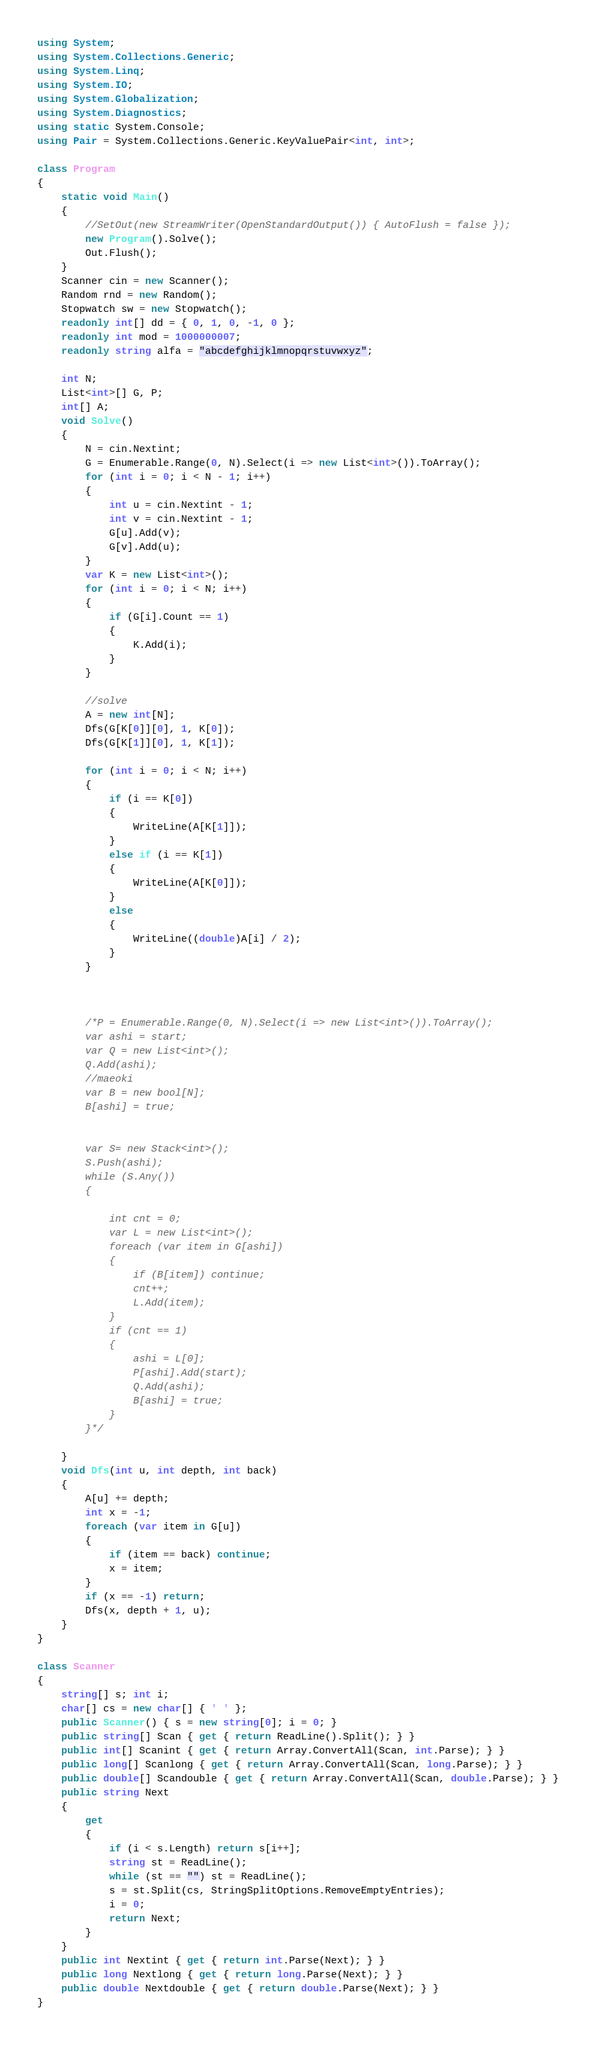<code> <loc_0><loc_0><loc_500><loc_500><_C#_>using System;
using System.Collections.Generic;
using System.Linq;
using System.IO;
using System.Globalization;
using System.Diagnostics;
using static System.Console;
using Pair = System.Collections.Generic.KeyValuePair<int, int>;

class Program
{
    static void Main()
    {
        //SetOut(new StreamWriter(OpenStandardOutput()) { AutoFlush = false });
        new Program().Solve();
        Out.Flush();
    }
    Scanner cin = new Scanner();
    Random rnd = new Random();
    Stopwatch sw = new Stopwatch();
    readonly int[] dd = { 0, 1, 0, -1, 0 };
    readonly int mod = 1000000007;
    readonly string alfa = "abcdefghijklmnopqrstuvwxyz";

    int N;
    List<int>[] G, P;
    int[] A;
    void Solve()
    {
        N = cin.Nextint;
        G = Enumerable.Range(0, N).Select(i => new List<int>()).ToArray();
        for (int i = 0; i < N - 1; i++)
        {
            int u = cin.Nextint - 1;
            int v = cin.Nextint - 1;
            G[u].Add(v);
            G[v].Add(u);
        }
        var K = new List<int>();
        for (int i = 0; i < N; i++)
        {
            if (G[i].Count == 1)
            {
                K.Add(i);
            }
        }

        //solve
        A = new int[N];
        Dfs(G[K[0]][0], 1, K[0]);
        Dfs(G[K[1]][0], 1, K[1]);

        for (int i = 0; i < N; i++)
        {
            if (i == K[0])
            {
                WriteLine(A[K[1]]);
            }
            else if (i == K[1])
            {
                WriteLine(A[K[0]]);
            }
            else
            {
                WriteLine((double)A[i] / 2);
            }
        }
            


        /*P = Enumerable.Range(0, N).Select(i => new List<int>()).ToArray();
        var ashi = start;
        var Q = new List<int>();
        Q.Add(ashi);
        //maeoki
        var B = new bool[N];
        B[ashi] = true;


        var S= new Stack<int>();
        S.Push(ashi);
        while (S.Any())
        {

            int cnt = 0;
            var L = new List<int>();
            foreach (var item in G[ashi])
            {
                if (B[item]) continue;
                cnt++;
                L.Add(item);
            }
            if (cnt == 1)
            {
                ashi = L[0];
                P[ashi].Add(start);
                Q.Add(ashi);
                B[ashi] = true;
            }
        }*/

    }
    void Dfs(int u, int depth, int back)
    {
        A[u] += depth;
        int x = -1;
        foreach (var item in G[u])
        {
            if (item == back) continue;
            x = item;
        }
        if (x == -1) return;
        Dfs(x, depth + 1, u);
    }
}

class Scanner
{
    string[] s; int i;
    char[] cs = new char[] { ' ' };
    public Scanner() { s = new string[0]; i = 0; }
    public string[] Scan { get { return ReadLine().Split(); } }
    public int[] Scanint { get { return Array.ConvertAll(Scan, int.Parse); } }
    public long[] Scanlong { get { return Array.ConvertAll(Scan, long.Parse); } }
    public double[] Scandouble { get { return Array.ConvertAll(Scan, double.Parse); } }
    public string Next
    {
        get
        {
            if (i < s.Length) return s[i++];
            string st = ReadLine();
            while (st == "") st = ReadLine();
            s = st.Split(cs, StringSplitOptions.RemoveEmptyEntries);
            i = 0;
            return Next;
        }
    }
    public int Nextint { get { return int.Parse(Next); } }
    public long Nextlong { get { return long.Parse(Next); } }
    public double Nextdouble { get { return double.Parse(Next); } }
}
</code> 